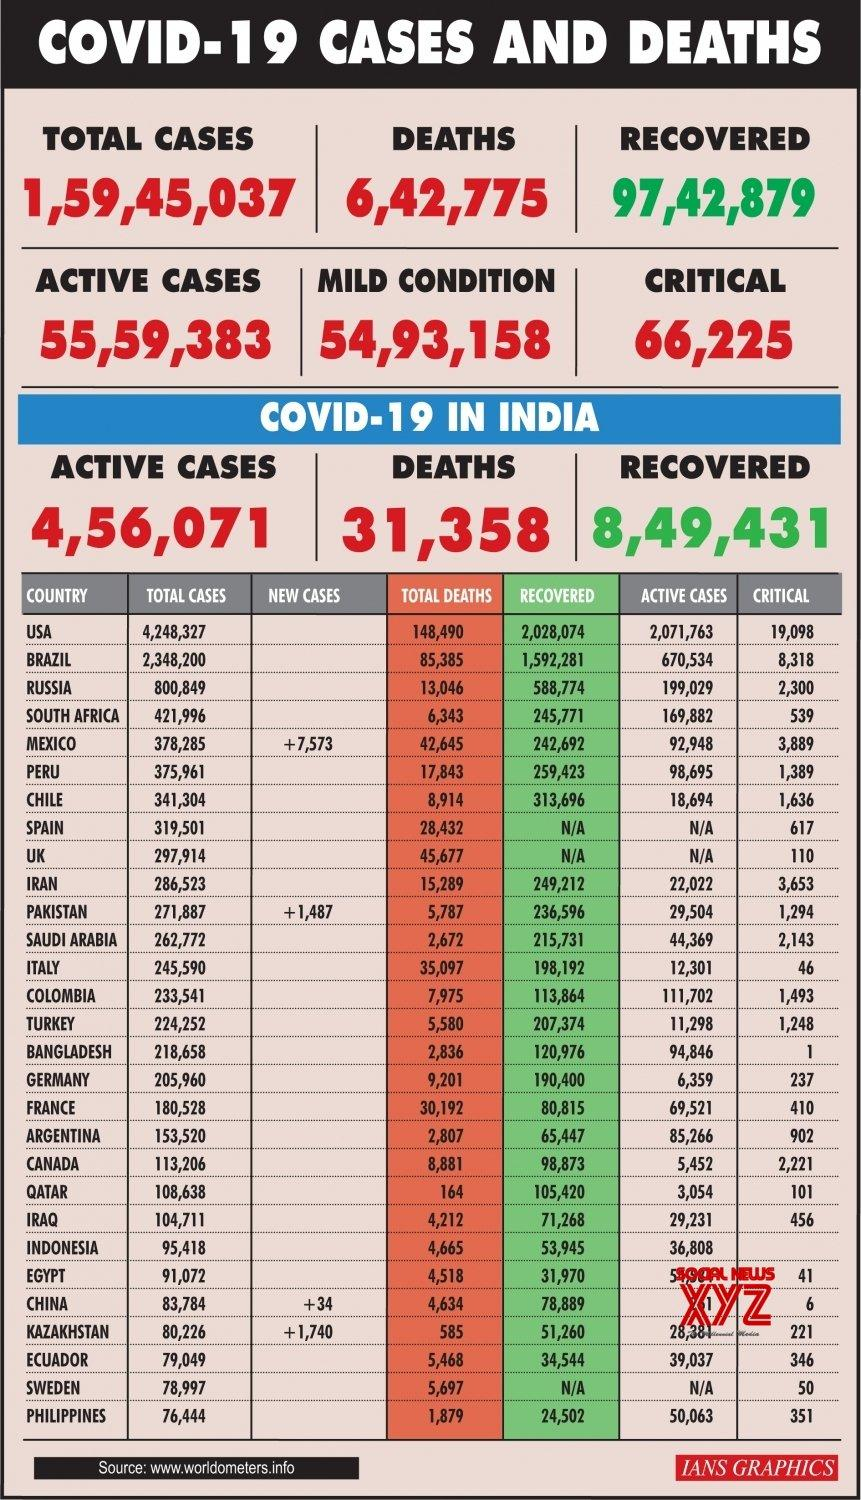Highlight a few significant elements in this photo. In Russia, a total of 588,774 cases of COVID-19 have been reported and successfully recovered as of April 2022. There have been 66,225 critical COVID-19 cases reported globally as of now. A total of 1,487 new COVID-19 cases were reported in Pakistan as of February 21, 2023. As of February 2023, the reported total number of COVID-19 deaths in Italy is 35,097. The United States of America has reported the highest number of COVID-19 cases globally. 